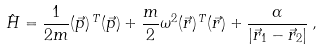<formula> <loc_0><loc_0><loc_500><loc_500>\hat { H } = \frac { 1 } { 2 m } ( \vec { p } ) ^ { \, T } ( \vec { p } ) + \frac { m } { 2 } \omega ^ { 2 } ( \vec { r } ) ^ { \, T } ( \vec { r } ) + \frac { \alpha } { | \vec { r } _ { 1 } - \vec { r } _ { 2 } | } \, ,</formula> 